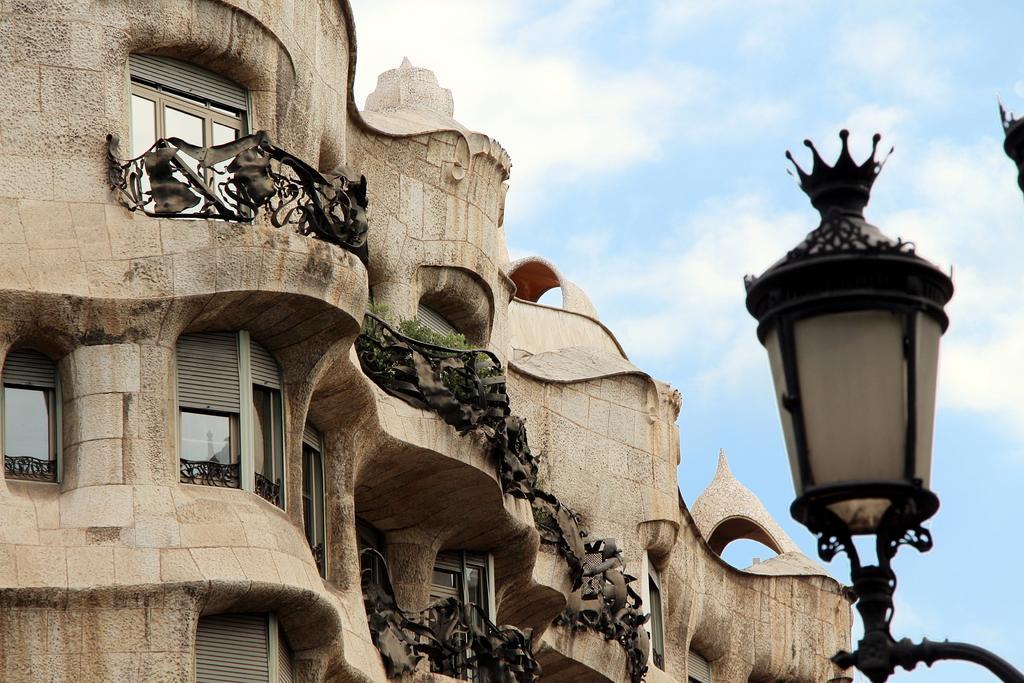How would you summarize this image in a sentence or two? In this image we can see a building with windows, the railing and some plants. On the right side we can see a street lamp and the sky which looks cloudy. 